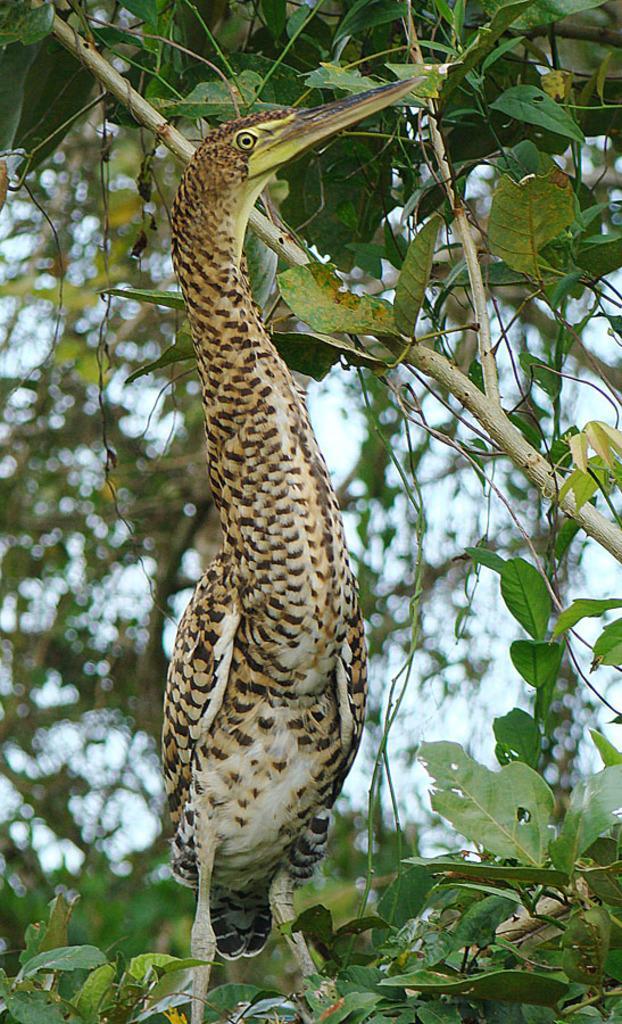Can you describe this image briefly? In this image we can see a bird, there are trees and the sky in the background. 